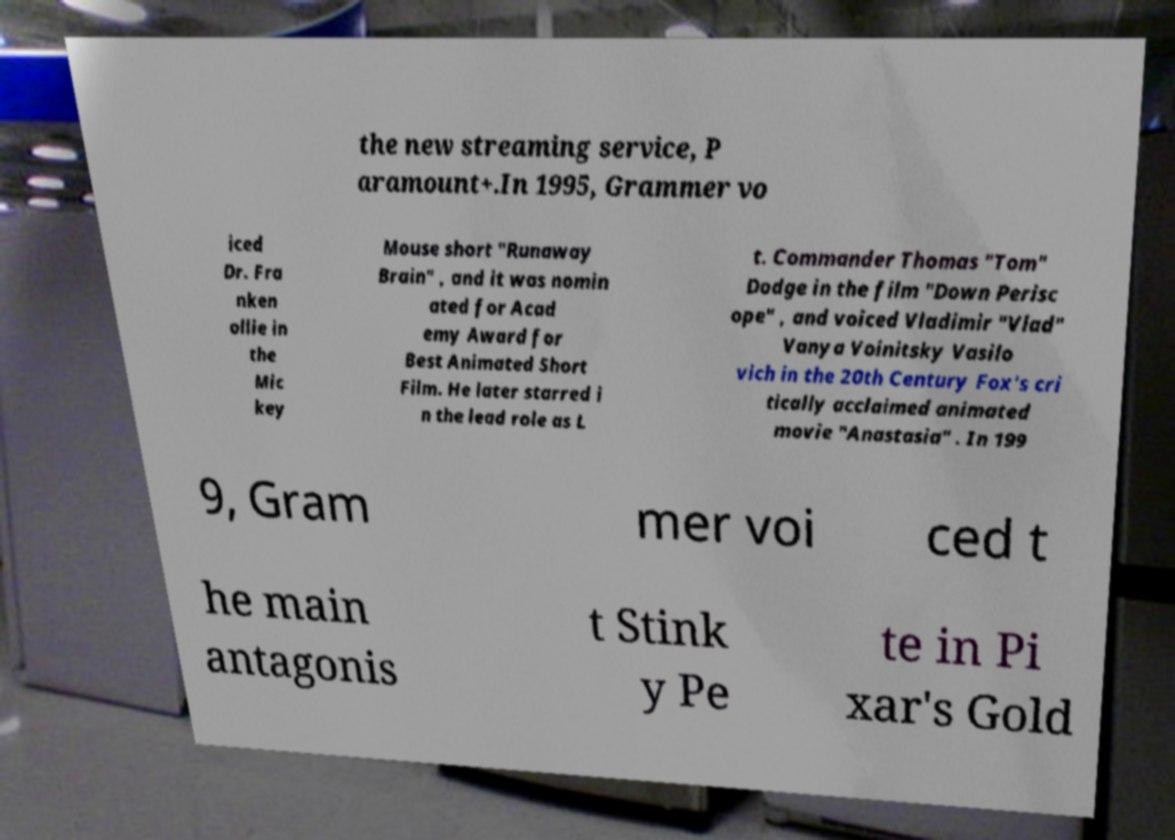Can you accurately transcribe the text from the provided image for me? the new streaming service, P aramount+.In 1995, Grammer vo iced Dr. Fra nken ollie in the Mic key Mouse short "Runaway Brain" , and it was nomin ated for Acad emy Award for Best Animated Short Film. He later starred i n the lead role as L t. Commander Thomas "Tom" Dodge in the film "Down Perisc ope" , and voiced Vladimir "Vlad" Vanya Voinitsky Vasilo vich in the 20th Century Fox's cri tically acclaimed animated movie "Anastasia" . In 199 9, Gram mer voi ced t he main antagonis t Stink y Pe te in Pi xar's Gold 